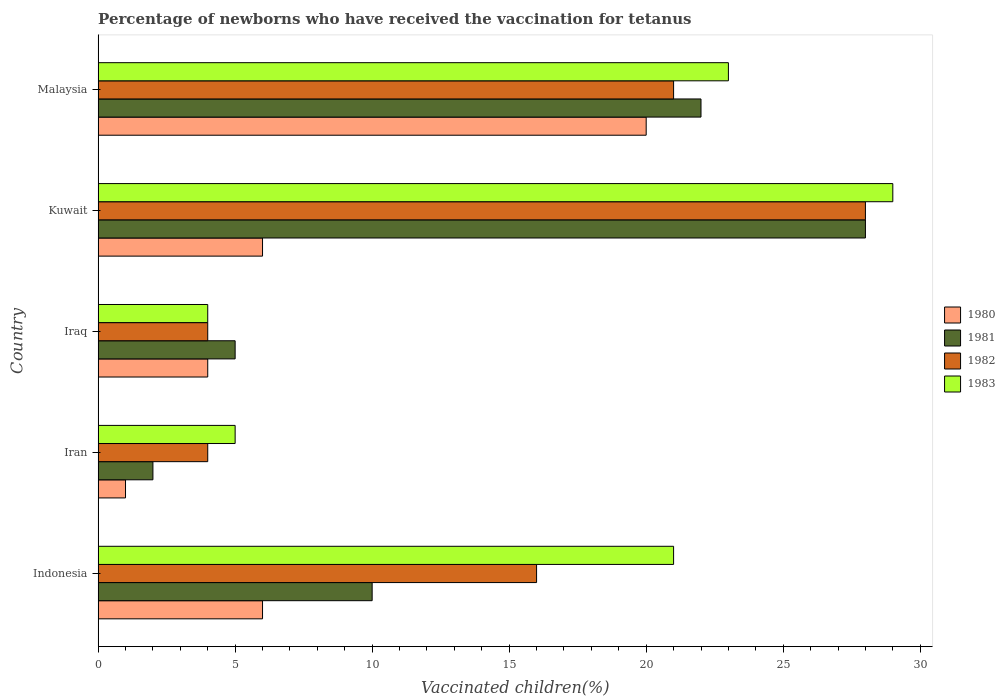Are the number of bars on each tick of the Y-axis equal?
Offer a terse response. Yes. How many bars are there on the 4th tick from the top?
Ensure brevity in your answer.  4. How many bars are there on the 2nd tick from the bottom?
Your response must be concise. 4. In which country was the percentage of vaccinated children in 1983 maximum?
Provide a succinct answer. Kuwait. In which country was the percentage of vaccinated children in 1981 minimum?
Offer a very short reply. Iran. What is the difference between the percentage of vaccinated children in 1983 in Malaysia and the percentage of vaccinated children in 1981 in Iran?
Offer a very short reply. 21. What is the average percentage of vaccinated children in 1982 per country?
Ensure brevity in your answer.  14.6. In how many countries, is the percentage of vaccinated children in 1983 greater than 15 %?
Your answer should be very brief. 3. What is the ratio of the percentage of vaccinated children in 1982 in Indonesia to that in Iran?
Provide a succinct answer. 4. Is the percentage of vaccinated children in 1982 in Iran less than that in Kuwait?
Ensure brevity in your answer.  Yes. What is the difference between the highest and the lowest percentage of vaccinated children in 1982?
Your answer should be compact. 24. In how many countries, is the percentage of vaccinated children in 1980 greater than the average percentage of vaccinated children in 1980 taken over all countries?
Offer a very short reply. 1. Is it the case that in every country, the sum of the percentage of vaccinated children in 1981 and percentage of vaccinated children in 1983 is greater than the sum of percentage of vaccinated children in 1982 and percentage of vaccinated children in 1980?
Provide a short and direct response. No. What does the 3rd bar from the top in Iran represents?
Provide a short and direct response. 1981. What does the 4th bar from the bottom in Iraq represents?
Provide a short and direct response. 1983. How many bars are there?
Provide a succinct answer. 20. Are all the bars in the graph horizontal?
Provide a short and direct response. Yes. How many countries are there in the graph?
Your response must be concise. 5. What is the difference between two consecutive major ticks on the X-axis?
Your response must be concise. 5. Does the graph contain any zero values?
Your answer should be very brief. No. Where does the legend appear in the graph?
Your answer should be compact. Center right. How many legend labels are there?
Offer a very short reply. 4. What is the title of the graph?
Offer a very short reply. Percentage of newborns who have received the vaccination for tetanus. What is the label or title of the X-axis?
Ensure brevity in your answer.  Vaccinated children(%). What is the label or title of the Y-axis?
Keep it short and to the point. Country. What is the Vaccinated children(%) in 1981 in Indonesia?
Offer a terse response. 10. What is the Vaccinated children(%) of 1982 in Indonesia?
Your answer should be compact. 16. What is the Vaccinated children(%) in 1981 in Iran?
Give a very brief answer. 2. What is the Vaccinated children(%) of 1982 in Iran?
Your answer should be compact. 4. What is the Vaccinated children(%) of 1980 in Iraq?
Your answer should be very brief. 4. What is the Vaccinated children(%) in 1981 in Iraq?
Provide a short and direct response. 5. What is the Vaccinated children(%) of 1983 in Iraq?
Offer a terse response. 4. What is the Vaccinated children(%) of 1982 in Kuwait?
Provide a succinct answer. 28. What is the Vaccinated children(%) in 1981 in Malaysia?
Provide a succinct answer. 22. Across all countries, what is the maximum Vaccinated children(%) in 1980?
Offer a terse response. 20. Across all countries, what is the maximum Vaccinated children(%) of 1982?
Give a very brief answer. 28. Across all countries, what is the minimum Vaccinated children(%) of 1980?
Offer a very short reply. 1. Across all countries, what is the minimum Vaccinated children(%) of 1981?
Offer a terse response. 2. Across all countries, what is the minimum Vaccinated children(%) of 1982?
Offer a terse response. 4. Across all countries, what is the minimum Vaccinated children(%) of 1983?
Your answer should be very brief. 4. What is the total Vaccinated children(%) in 1980 in the graph?
Provide a succinct answer. 37. What is the difference between the Vaccinated children(%) of 1980 in Indonesia and that in Iran?
Your answer should be very brief. 5. What is the difference between the Vaccinated children(%) in 1981 in Indonesia and that in Iran?
Offer a terse response. 8. What is the difference between the Vaccinated children(%) of 1982 in Indonesia and that in Iran?
Keep it short and to the point. 12. What is the difference between the Vaccinated children(%) of 1980 in Indonesia and that in Iraq?
Keep it short and to the point. 2. What is the difference between the Vaccinated children(%) of 1982 in Indonesia and that in Iraq?
Offer a terse response. 12. What is the difference between the Vaccinated children(%) in 1983 in Indonesia and that in Iraq?
Your response must be concise. 17. What is the difference between the Vaccinated children(%) in 1981 in Indonesia and that in Kuwait?
Your answer should be compact. -18. What is the difference between the Vaccinated children(%) of 1980 in Indonesia and that in Malaysia?
Your response must be concise. -14. What is the difference between the Vaccinated children(%) in 1981 in Indonesia and that in Malaysia?
Your answer should be compact. -12. What is the difference between the Vaccinated children(%) of 1982 in Indonesia and that in Malaysia?
Your response must be concise. -5. What is the difference between the Vaccinated children(%) of 1982 in Iran and that in Iraq?
Your answer should be very brief. 0. What is the difference between the Vaccinated children(%) of 1983 in Iran and that in Kuwait?
Offer a terse response. -24. What is the difference between the Vaccinated children(%) in 1980 in Iran and that in Malaysia?
Ensure brevity in your answer.  -19. What is the difference between the Vaccinated children(%) of 1982 in Iran and that in Malaysia?
Keep it short and to the point. -17. What is the difference between the Vaccinated children(%) in 1983 in Iran and that in Malaysia?
Your answer should be compact. -18. What is the difference between the Vaccinated children(%) in 1980 in Iraq and that in Kuwait?
Your answer should be very brief. -2. What is the difference between the Vaccinated children(%) in 1980 in Iraq and that in Malaysia?
Offer a very short reply. -16. What is the difference between the Vaccinated children(%) of 1982 in Iraq and that in Malaysia?
Offer a very short reply. -17. What is the difference between the Vaccinated children(%) of 1983 in Iraq and that in Malaysia?
Keep it short and to the point. -19. What is the difference between the Vaccinated children(%) in 1981 in Kuwait and that in Malaysia?
Your answer should be very brief. 6. What is the difference between the Vaccinated children(%) in 1980 in Indonesia and the Vaccinated children(%) in 1981 in Iran?
Make the answer very short. 4. What is the difference between the Vaccinated children(%) in 1981 in Indonesia and the Vaccinated children(%) in 1983 in Iran?
Your response must be concise. 5. What is the difference between the Vaccinated children(%) in 1982 in Indonesia and the Vaccinated children(%) in 1983 in Iran?
Give a very brief answer. 11. What is the difference between the Vaccinated children(%) of 1980 in Indonesia and the Vaccinated children(%) of 1981 in Iraq?
Offer a terse response. 1. What is the difference between the Vaccinated children(%) in 1980 in Indonesia and the Vaccinated children(%) in 1983 in Iraq?
Provide a succinct answer. 2. What is the difference between the Vaccinated children(%) in 1981 in Indonesia and the Vaccinated children(%) in 1982 in Iraq?
Provide a short and direct response. 6. What is the difference between the Vaccinated children(%) of 1980 in Indonesia and the Vaccinated children(%) of 1982 in Kuwait?
Give a very brief answer. -22. What is the difference between the Vaccinated children(%) in 1980 in Indonesia and the Vaccinated children(%) in 1983 in Kuwait?
Give a very brief answer. -23. What is the difference between the Vaccinated children(%) of 1981 in Indonesia and the Vaccinated children(%) of 1982 in Kuwait?
Your answer should be very brief. -18. What is the difference between the Vaccinated children(%) in 1981 in Indonesia and the Vaccinated children(%) in 1983 in Kuwait?
Keep it short and to the point. -19. What is the difference between the Vaccinated children(%) of 1980 in Indonesia and the Vaccinated children(%) of 1981 in Malaysia?
Offer a very short reply. -16. What is the difference between the Vaccinated children(%) of 1981 in Indonesia and the Vaccinated children(%) of 1982 in Malaysia?
Your response must be concise. -11. What is the difference between the Vaccinated children(%) of 1981 in Indonesia and the Vaccinated children(%) of 1983 in Malaysia?
Offer a very short reply. -13. What is the difference between the Vaccinated children(%) of 1980 in Iran and the Vaccinated children(%) of 1981 in Iraq?
Provide a short and direct response. -4. What is the difference between the Vaccinated children(%) of 1980 in Iran and the Vaccinated children(%) of 1982 in Iraq?
Ensure brevity in your answer.  -3. What is the difference between the Vaccinated children(%) in 1980 in Iran and the Vaccinated children(%) in 1983 in Iraq?
Provide a short and direct response. -3. What is the difference between the Vaccinated children(%) of 1981 in Iran and the Vaccinated children(%) of 1983 in Iraq?
Your answer should be compact. -2. What is the difference between the Vaccinated children(%) of 1980 in Iran and the Vaccinated children(%) of 1981 in Kuwait?
Your answer should be very brief. -27. What is the difference between the Vaccinated children(%) of 1980 in Iran and the Vaccinated children(%) of 1983 in Kuwait?
Provide a short and direct response. -28. What is the difference between the Vaccinated children(%) of 1981 in Iran and the Vaccinated children(%) of 1983 in Kuwait?
Offer a terse response. -27. What is the difference between the Vaccinated children(%) of 1980 in Iran and the Vaccinated children(%) of 1982 in Malaysia?
Provide a short and direct response. -20. What is the difference between the Vaccinated children(%) in 1981 in Iran and the Vaccinated children(%) in 1983 in Malaysia?
Make the answer very short. -21. What is the difference between the Vaccinated children(%) in 1980 in Iraq and the Vaccinated children(%) in 1982 in Kuwait?
Offer a very short reply. -24. What is the difference between the Vaccinated children(%) in 1981 in Iraq and the Vaccinated children(%) in 1982 in Kuwait?
Your answer should be compact. -23. What is the difference between the Vaccinated children(%) of 1981 in Iraq and the Vaccinated children(%) of 1983 in Kuwait?
Keep it short and to the point. -24. What is the difference between the Vaccinated children(%) in 1982 in Iraq and the Vaccinated children(%) in 1983 in Kuwait?
Keep it short and to the point. -25. What is the difference between the Vaccinated children(%) in 1980 in Iraq and the Vaccinated children(%) in 1982 in Malaysia?
Offer a terse response. -17. What is the difference between the Vaccinated children(%) of 1980 in Kuwait and the Vaccinated children(%) of 1981 in Malaysia?
Your answer should be compact. -16. What is the difference between the Vaccinated children(%) of 1980 in Kuwait and the Vaccinated children(%) of 1982 in Malaysia?
Offer a very short reply. -15. What is the difference between the Vaccinated children(%) in 1980 in Kuwait and the Vaccinated children(%) in 1983 in Malaysia?
Your response must be concise. -17. What is the difference between the Vaccinated children(%) of 1981 in Kuwait and the Vaccinated children(%) of 1983 in Malaysia?
Make the answer very short. 5. What is the difference between the Vaccinated children(%) in 1982 in Kuwait and the Vaccinated children(%) in 1983 in Malaysia?
Offer a terse response. 5. What is the average Vaccinated children(%) of 1981 per country?
Provide a succinct answer. 13.4. What is the average Vaccinated children(%) of 1982 per country?
Your response must be concise. 14.6. What is the average Vaccinated children(%) of 1983 per country?
Your answer should be compact. 16.4. What is the difference between the Vaccinated children(%) in 1980 and Vaccinated children(%) in 1981 in Indonesia?
Offer a terse response. -4. What is the difference between the Vaccinated children(%) in 1980 and Vaccinated children(%) in 1982 in Indonesia?
Your answer should be compact. -10. What is the difference between the Vaccinated children(%) of 1981 and Vaccinated children(%) of 1982 in Indonesia?
Offer a terse response. -6. What is the difference between the Vaccinated children(%) in 1981 and Vaccinated children(%) in 1983 in Indonesia?
Offer a very short reply. -11. What is the difference between the Vaccinated children(%) in 1980 and Vaccinated children(%) in 1981 in Iran?
Offer a very short reply. -1. What is the difference between the Vaccinated children(%) of 1980 and Vaccinated children(%) of 1983 in Iran?
Ensure brevity in your answer.  -4. What is the difference between the Vaccinated children(%) in 1982 and Vaccinated children(%) in 1983 in Iran?
Your answer should be compact. -1. What is the difference between the Vaccinated children(%) of 1980 and Vaccinated children(%) of 1981 in Iraq?
Offer a terse response. -1. What is the difference between the Vaccinated children(%) in 1980 and Vaccinated children(%) in 1982 in Iraq?
Give a very brief answer. 0. What is the difference between the Vaccinated children(%) of 1981 and Vaccinated children(%) of 1982 in Iraq?
Your response must be concise. 1. What is the difference between the Vaccinated children(%) of 1981 and Vaccinated children(%) of 1983 in Iraq?
Your answer should be compact. 1. What is the difference between the Vaccinated children(%) of 1980 and Vaccinated children(%) of 1983 in Kuwait?
Give a very brief answer. -23. What is the difference between the Vaccinated children(%) in 1981 and Vaccinated children(%) in 1982 in Kuwait?
Ensure brevity in your answer.  0. What is the difference between the Vaccinated children(%) in 1980 and Vaccinated children(%) in 1981 in Malaysia?
Give a very brief answer. -2. What is the difference between the Vaccinated children(%) of 1980 and Vaccinated children(%) of 1982 in Malaysia?
Your answer should be compact. -1. What is the difference between the Vaccinated children(%) of 1980 and Vaccinated children(%) of 1983 in Malaysia?
Provide a short and direct response. -3. What is the difference between the Vaccinated children(%) of 1981 and Vaccinated children(%) of 1983 in Malaysia?
Offer a terse response. -1. What is the difference between the Vaccinated children(%) of 1982 and Vaccinated children(%) of 1983 in Malaysia?
Provide a succinct answer. -2. What is the ratio of the Vaccinated children(%) in 1980 in Indonesia to that in Iran?
Your response must be concise. 6. What is the ratio of the Vaccinated children(%) in 1982 in Indonesia to that in Iran?
Give a very brief answer. 4. What is the ratio of the Vaccinated children(%) of 1980 in Indonesia to that in Iraq?
Make the answer very short. 1.5. What is the ratio of the Vaccinated children(%) of 1983 in Indonesia to that in Iraq?
Offer a very short reply. 5.25. What is the ratio of the Vaccinated children(%) of 1981 in Indonesia to that in Kuwait?
Offer a very short reply. 0.36. What is the ratio of the Vaccinated children(%) in 1983 in Indonesia to that in Kuwait?
Your response must be concise. 0.72. What is the ratio of the Vaccinated children(%) of 1980 in Indonesia to that in Malaysia?
Your answer should be very brief. 0.3. What is the ratio of the Vaccinated children(%) in 1981 in Indonesia to that in Malaysia?
Make the answer very short. 0.45. What is the ratio of the Vaccinated children(%) of 1982 in Indonesia to that in Malaysia?
Make the answer very short. 0.76. What is the ratio of the Vaccinated children(%) of 1980 in Iran to that in Iraq?
Provide a short and direct response. 0.25. What is the ratio of the Vaccinated children(%) in 1981 in Iran to that in Iraq?
Your answer should be very brief. 0.4. What is the ratio of the Vaccinated children(%) of 1983 in Iran to that in Iraq?
Keep it short and to the point. 1.25. What is the ratio of the Vaccinated children(%) in 1980 in Iran to that in Kuwait?
Make the answer very short. 0.17. What is the ratio of the Vaccinated children(%) in 1981 in Iran to that in Kuwait?
Your answer should be compact. 0.07. What is the ratio of the Vaccinated children(%) of 1982 in Iran to that in Kuwait?
Provide a succinct answer. 0.14. What is the ratio of the Vaccinated children(%) of 1983 in Iran to that in Kuwait?
Offer a very short reply. 0.17. What is the ratio of the Vaccinated children(%) of 1980 in Iran to that in Malaysia?
Your answer should be compact. 0.05. What is the ratio of the Vaccinated children(%) in 1981 in Iran to that in Malaysia?
Keep it short and to the point. 0.09. What is the ratio of the Vaccinated children(%) of 1982 in Iran to that in Malaysia?
Provide a short and direct response. 0.19. What is the ratio of the Vaccinated children(%) of 1983 in Iran to that in Malaysia?
Offer a very short reply. 0.22. What is the ratio of the Vaccinated children(%) in 1981 in Iraq to that in Kuwait?
Your answer should be very brief. 0.18. What is the ratio of the Vaccinated children(%) in 1982 in Iraq to that in Kuwait?
Make the answer very short. 0.14. What is the ratio of the Vaccinated children(%) in 1983 in Iraq to that in Kuwait?
Provide a succinct answer. 0.14. What is the ratio of the Vaccinated children(%) of 1981 in Iraq to that in Malaysia?
Make the answer very short. 0.23. What is the ratio of the Vaccinated children(%) in 1982 in Iraq to that in Malaysia?
Ensure brevity in your answer.  0.19. What is the ratio of the Vaccinated children(%) in 1983 in Iraq to that in Malaysia?
Offer a terse response. 0.17. What is the ratio of the Vaccinated children(%) of 1980 in Kuwait to that in Malaysia?
Give a very brief answer. 0.3. What is the ratio of the Vaccinated children(%) of 1981 in Kuwait to that in Malaysia?
Keep it short and to the point. 1.27. What is the ratio of the Vaccinated children(%) of 1983 in Kuwait to that in Malaysia?
Provide a succinct answer. 1.26. What is the difference between the highest and the second highest Vaccinated children(%) of 1982?
Ensure brevity in your answer.  7. What is the difference between the highest and the lowest Vaccinated children(%) in 1980?
Offer a terse response. 19. What is the difference between the highest and the lowest Vaccinated children(%) of 1981?
Keep it short and to the point. 26. What is the difference between the highest and the lowest Vaccinated children(%) of 1982?
Offer a terse response. 24. What is the difference between the highest and the lowest Vaccinated children(%) of 1983?
Your answer should be compact. 25. 